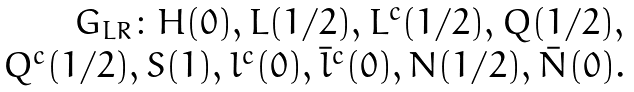<formula> <loc_0><loc_0><loc_500><loc_500>\begin{array} { r l c } G _ { L R } \colon H ( 0 ) , L ( 1 / 2 ) , L ^ { c } ( 1 / 2 ) , Q ( 1 / 2 ) , \\ Q ^ { c } ( 1 / 2 ) , S ( 1 ) , l ^ { c } ( 0 ) , \bar { l } ^ { c } ( 0 ) , N ( 1 / 2 ) , \bar { N } ( 0 ) . \end{array}</formula> 